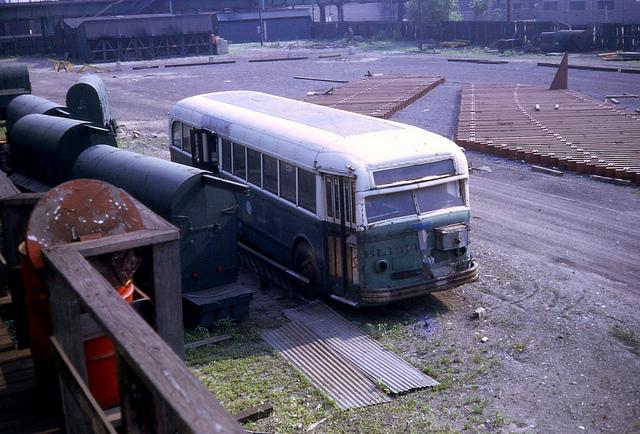What color is the top of the bus?
Answer briefly. White. How many buses are there?
Short answer required. 1. What type of vehicle is this?
Keep it brief. Bus. 